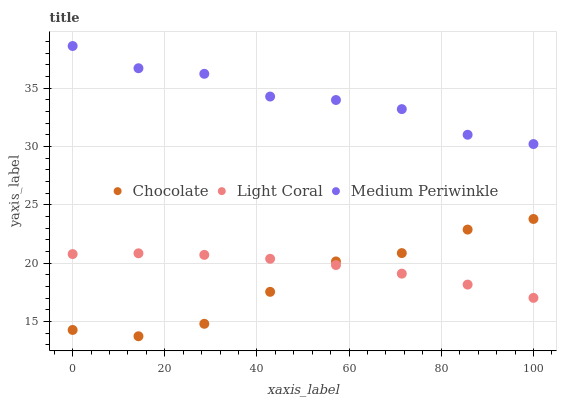Does Chocolate have the minimum area under the curve?
Answer yes or no. Yes. Does Medium Periwinkle have the maximum area under the curve?
Answer yes or no. Yes. Does Medium Periwinkle have the minimum area under the curve?
Answer yes or no. No. Does Chocolate have the maximum area under the curve?
Answer yes or no. No. Is Light Coral the smoothest?
Answer yes or no. Yes. Is Medium Periwinkle the roughest?
Answer yes or no. Yes. Is Chocolate the smoothest?
Answer yes or no. No. Is Chocolate the roughest?
Answer yes or no. No. Does Chocolate have the lowest value?
Answer yes or no. Yes. Does Medium Periwinkle have the lowest value?
Answer yes or no. No. Does Medium Periwinkle have the highest value?
Answer yes or no. Yes. Does Chocolate have the highest value?
Answer yes or no. No. Is Light Coral less than Medium Periwinkle?
Answer yes or no. Yes. Is Medium Periwinkle greater than Light Coral?
Answer yes or no. Yes. Does Light Coral intersect Chocolate?
Answer yes or no. Yes. Is Light Coral less than Chocolate?
Answer yes or no. No. Is Light Coral greater than Chocolate?
Answer yes or no. No. Does Light Coral intersect Medium Periwinkle?
Answer yes or no. No. 